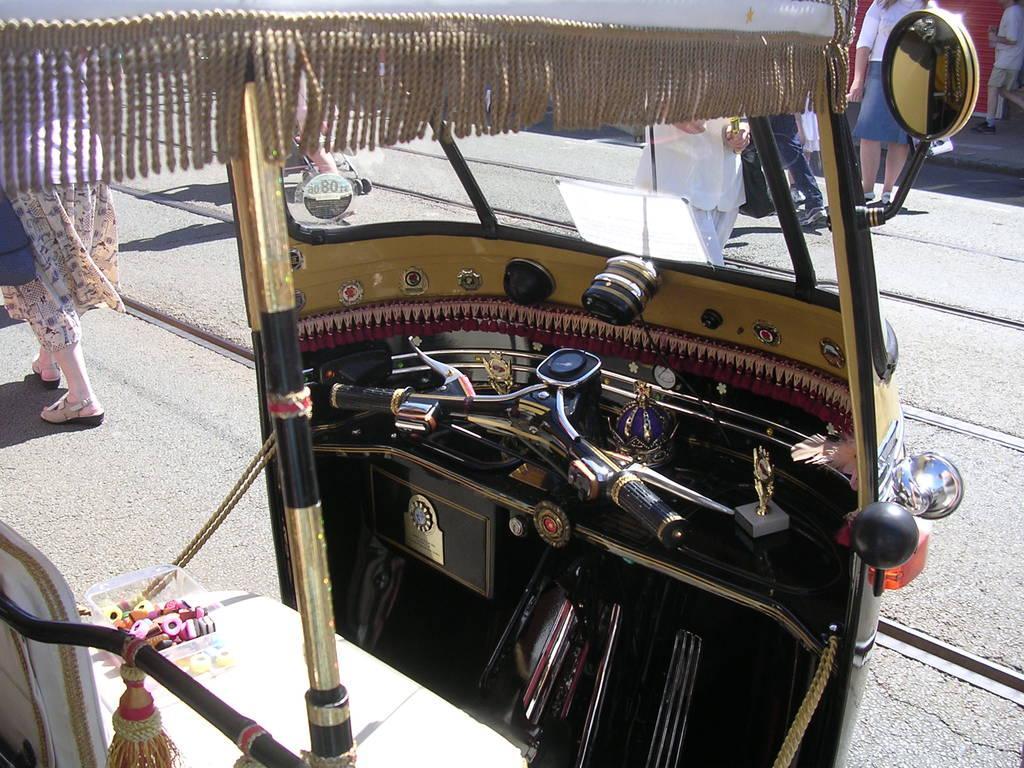Please provide a concise description of this image. There is a vehicle on the road. Here we can see few persons. 